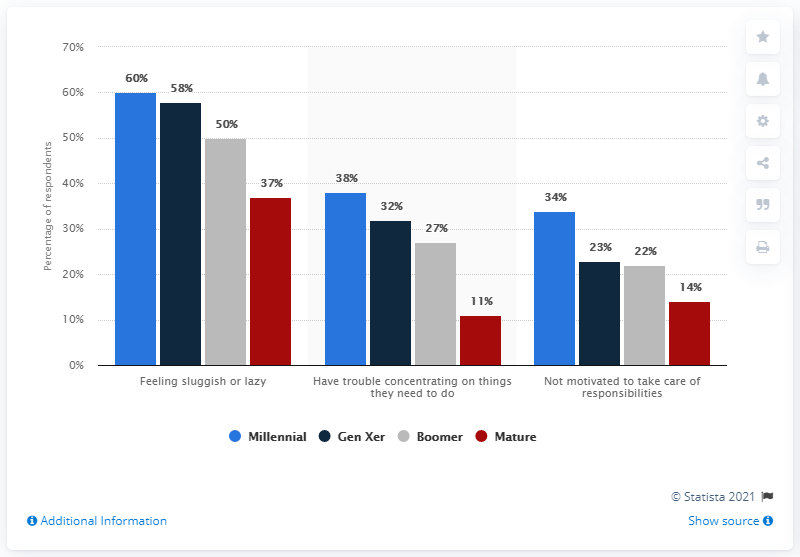Outline some significant characteristics in this image. According to a survey conducted in 2013, the generation with the highest percentage of teens and adults who reported experiencing consequences due to poor sleeping habits was millennials. The difference between the highest and lowest Millennial value is 26. 